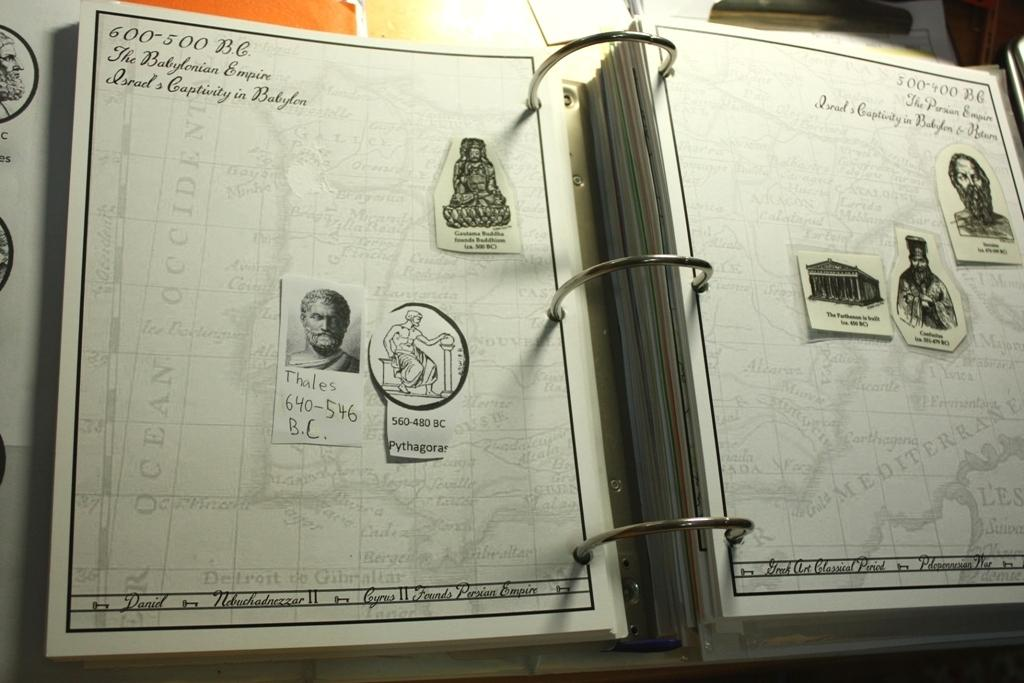What object can be seen in the picture? There is a book in the picture. What is unique about the book? The book has photos on it. Is there any text on the book? Yes, there is writing on the book. What type of surprise can be found inside the box in the image? There is no box present in the image, so it is not possible to determine what, if any, surprise might be found inside. 